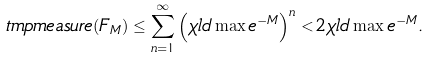Convert formula to latex. <formula><loc_0><loc_0><loc_500><loc_500>\ t m p m e a s u r e ( F _ { M } ) \leq \sum _ { n = 1 } ^ { \infty } \left ( \chi l d \max e ^ { - M } \right ) ^ { n } < 2 \chi l d \max e ^ { - M } .</formula> 